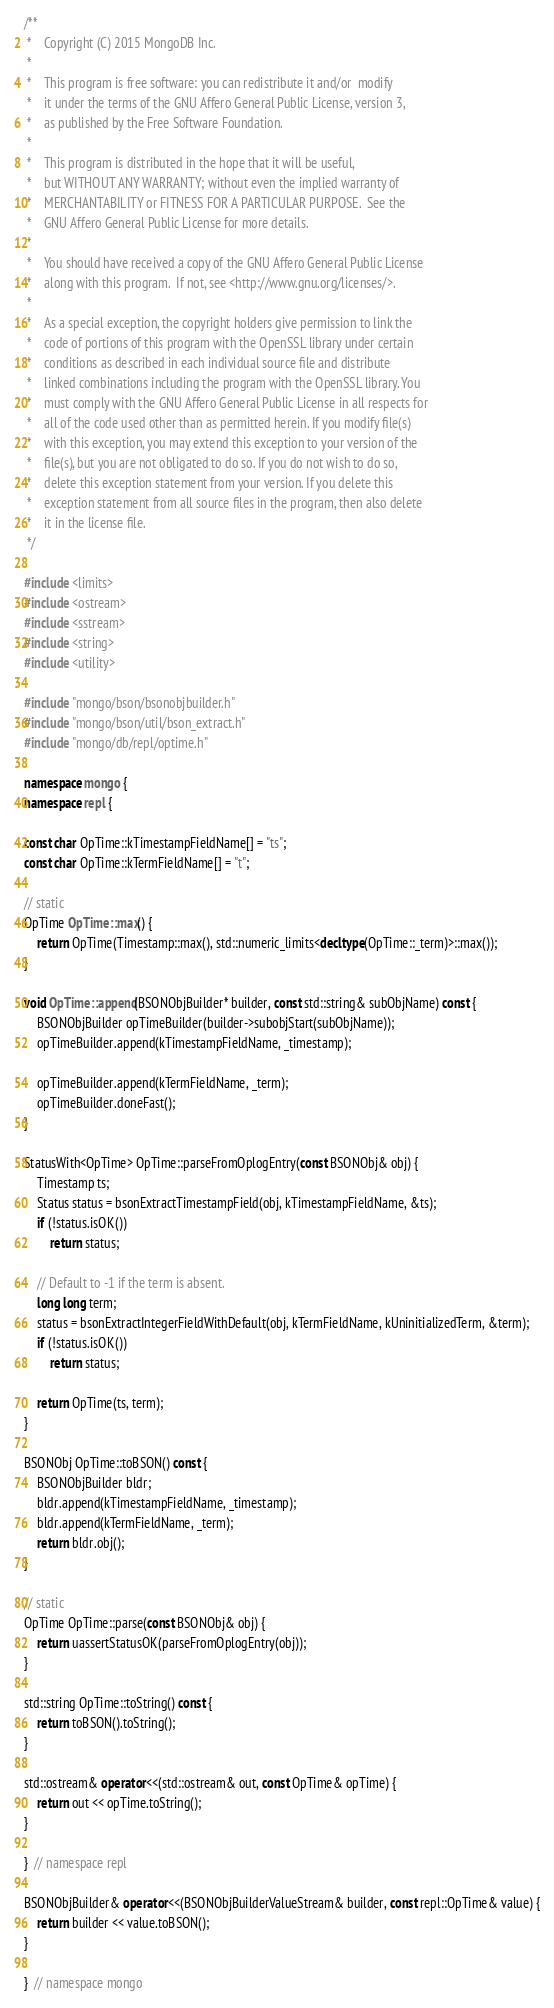Convert code to text. <code><loc_0><loc_0><loc_500><loc_500><_C++_>/**
 *    Copyright (C) 2015 MongoDB Inc.
 *
 *    This program is free software: you can redistribute it and/or  modify
 *    it under the terms of the GNU Affero General Public License, version 3,
 *    as published by the Free Software Foundation.
 *
 *    This program is distributed in the hope that it will be useful,
 *    but WITHOUT ANY WARRANTY; without even the implied warranty of
 *    MERCHANTABILITY or FITNESS FOR A PARTICULAR PURPOSE.  See the
 *    GNU Affero General Public License for more details.
 *
 *    You should have received a copy of the GNU Affero General Public License
 *    along with this program.  If not, see <http://www.gnu.org/licenses/>.
 *
 *    As a special exception, the copyright holders give permission to link the
 *    code of portions of this program with the OpenSSL library under certain
 *    conditions as described in each individual source file and distribute
 *    linked combinations including the program with the OpenSSL library. You
 *    must comply with the GNU Affero General Public License in all respects for
 *    all of the code used other than as permitted herein. If you modify file(s)
 *    with this exception, you may extend this exception to your version of the
 *    file(s), but you are not obligated to do so. If you do not wish to do so,
 *    delete this exception statement from your version. If you delete this
 *    exception statement from all source files in the program, then also delete
 *    it in the license file.
 */

#include <limits>
#include <ostream>
#include <sstream>
#include <string>
#include <utility>

#include "mongo/bson/bsonobjbuilder.h"
#include "mongo/bson/util/bson_extract.h"
#include "mongo/db/repl/optime.h"

namespace mongo {
namespace repl {

const char OpTime::kTimestampFieldName[] = "ts";
const char OpTime::kTermFieldName[] = "t";

// static
OpTime OpTime::max() {
    return OpTime(Timestamp::max(), std::numeric_limits<decltype(OpTime::_term)>::max());
}

void OpTime::append(BSONObjBuilder* builder, const std::string& subObjName) const {
    BSONObjBuilder opTimeBuilder(builder->subobjStart(subObjName));
    opTimeBuilder.append(kTimestampFieldName, _timestamp);

    opTimeBuilder.append(kTermFieldName, _term);
    opTimeBuilder.doneFast();
}

StatusWith<OpTime> OpTime::parseFromOplogEntry(const BSONObj& obj) {
    Timestamp ts;
    Status status = bsonExtractTimestampField(obj, kTimestampFieldName, &ts);
    if (!status.isOK())
        return status;

    // Default to -1 if the term is absent.
    long long term;
    status = bsonExtractIntegerFieldWithDefault(obj, kTermFieldName, kUninitializedTerm, &term);
    if (!status.isOK())
        return status;

    return OpTime(ts, term);
}

BSONObj OpTime::toBSON() const {
    BSONObjBuilder bldr;
    bldr.append(kTimestampFieldName, _timestamp);
    bldr.append(kTermFieldName, _term);
    return bldr.obj();
}

// static
OpTime OpTime::parse(const BSONObj& obj) {
    return uassertStatusOK(parseFromOplogEntry(obj));
}

std::string OpTime::toString() const {
    return toBSON().toString();
}

std::ostream& operator<<(std::ostream& out, const OpTime& opTime) {
    return out << opTime.toString();
}

}  // namespace repl

BSONObjBuilder& operator<<(BSONObjBuilderValueStream& builder, const repl::OpTime& value) {
    return builder << value.toBSON();
}

}  // namespace mongo
</code> 